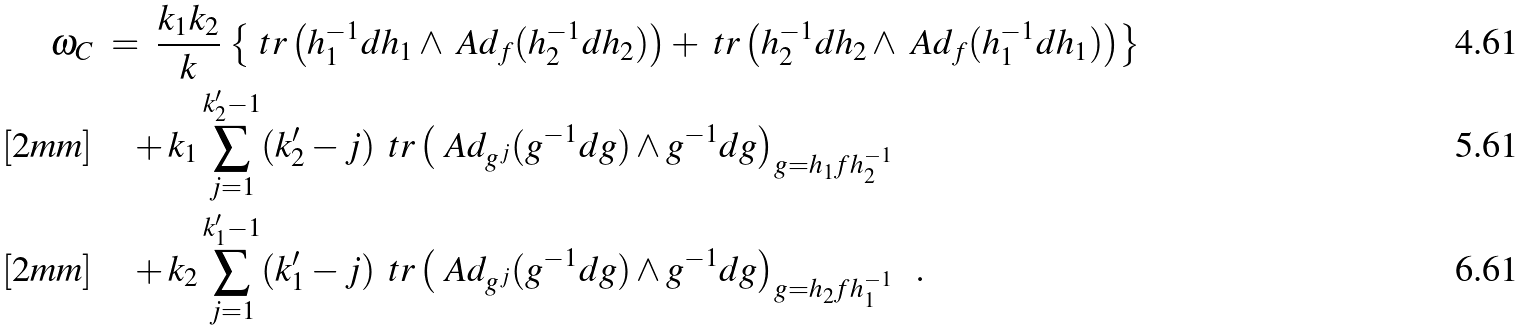<formula> <loc_0><loc_0><loc_500><loc_500>\omega _ { C } & \ = \ \frac { k _ { 1 } k _ { 2 } } { k } \, \left \{ \ t r \left ( h _ { 1 } ^ { - 1 } d h _ { 1 } \wedge \ A d _ { f } ( h _ { 2 } ^ { - 1 } d h _ { 2 } ) \right ) + \ t r \left ( h _ { 2 } ^ { - 1 } d h _ { 2 } \wedge \ A d _ { f } ( h _ { 1 } ^ { - 1 } d h _ { 1 } ) \right ) \right \} \\ [ 2 m m ] & \quad + k _ { 1 } \sum _ { j = 1 } ^ { k ^ { \prime } _ { 2 } - 1 } ( k ^ { \prime } _ { 2 } - j ) \, \ t r \left ( \ A d _ { g ^ { j } } ( g ^ { - 1 } d g ) \wedge g ^ { - 1 } d g \right ) _ { g = h _ { 1 } f h _ { 2 } ^ { - 1 } } \\ [ 2 m m ] & \quad + k _ { 2 } \sum _ { j = 1 } ^ { k ^ { \prime } _ { 1 } - 1 } ( k ^ { \prime } _ { 1 } - j ) \, \ t r \left ( \ A d _ { g ^ { j } } ( g ^ { - 1 } d g ) \wedge g ^ { - 1 } d g \right ) _ { g = h _ { 2 } f h _ { 1 } ^ { - 1 } } \ \ .</formula> 